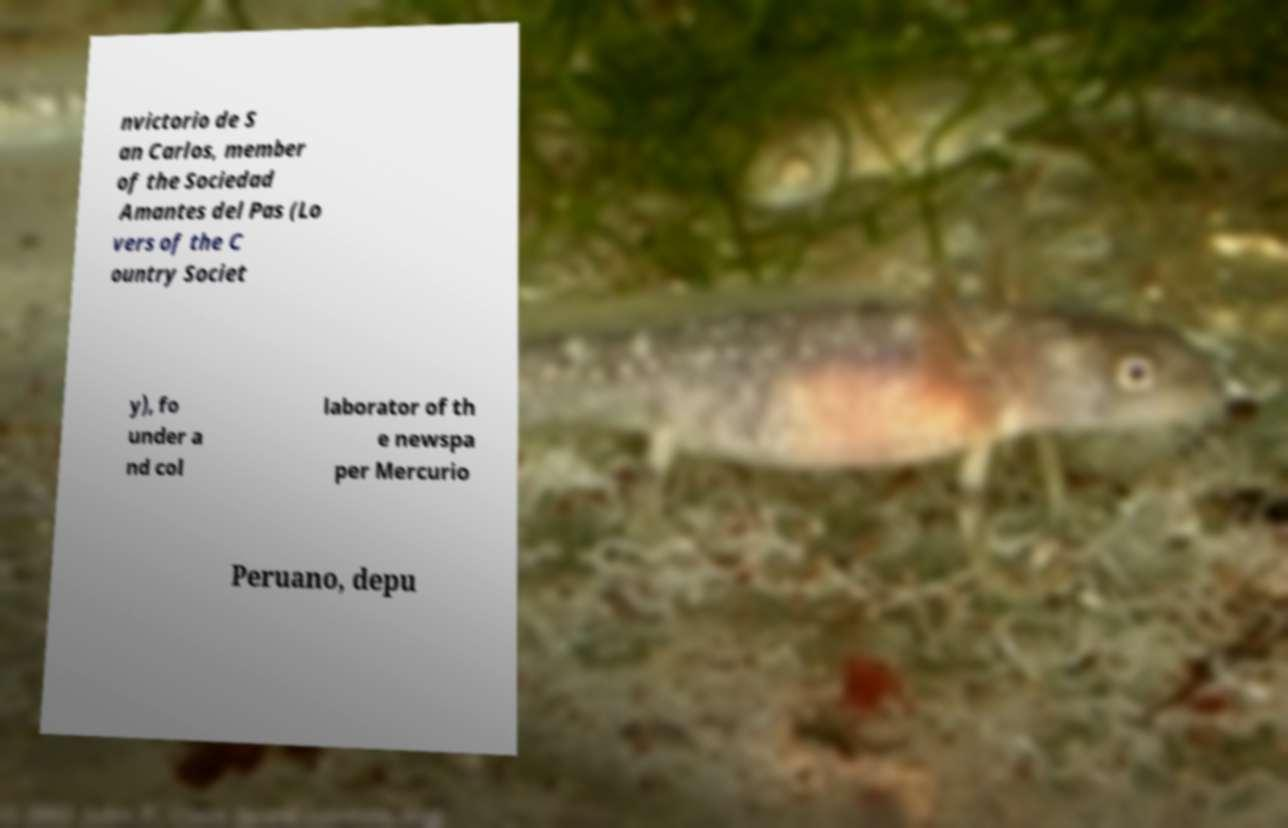I need the written content from this picture converted into text. Can you do that? nvictorio de S an Carlos, member of the Sociedad Amantes del Pas (Lo vers of the C ountry Societ y), fo under a nd col laborator of th e newspa per Mercurio Peruano, depu 